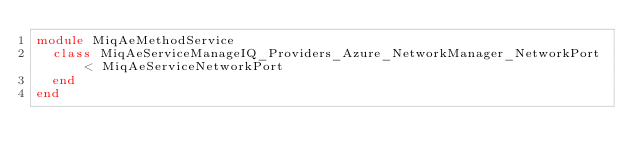Convert code to text. <code><loc_0><loc_0><loc_500><loc_500><_Ruby_>module MiqAeMethodService
  class MiqAeServiceManageIQ_Providers_Azure_NetworkManager_NetworkPort < MiqAeServiceNetworkPort
  end
end
</code> 